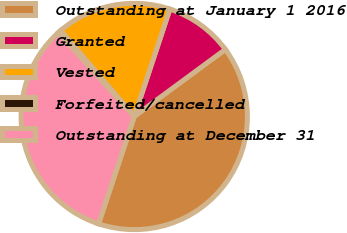Convert chart to OTSL. <chart><loc_0><loc_0><loc_500><loc_500><pie_chart><fcel>Outstanding at January 1 2016<fcel>Granted<fcel>Vested<fcel>Forfeited/cancelled<fcel>Outstanding at December 31<nl><fcel>40.2%<fcel>9.8%<fcel>16.38%<fcel>0.39%<fcel>33.22%<nl></chart> 